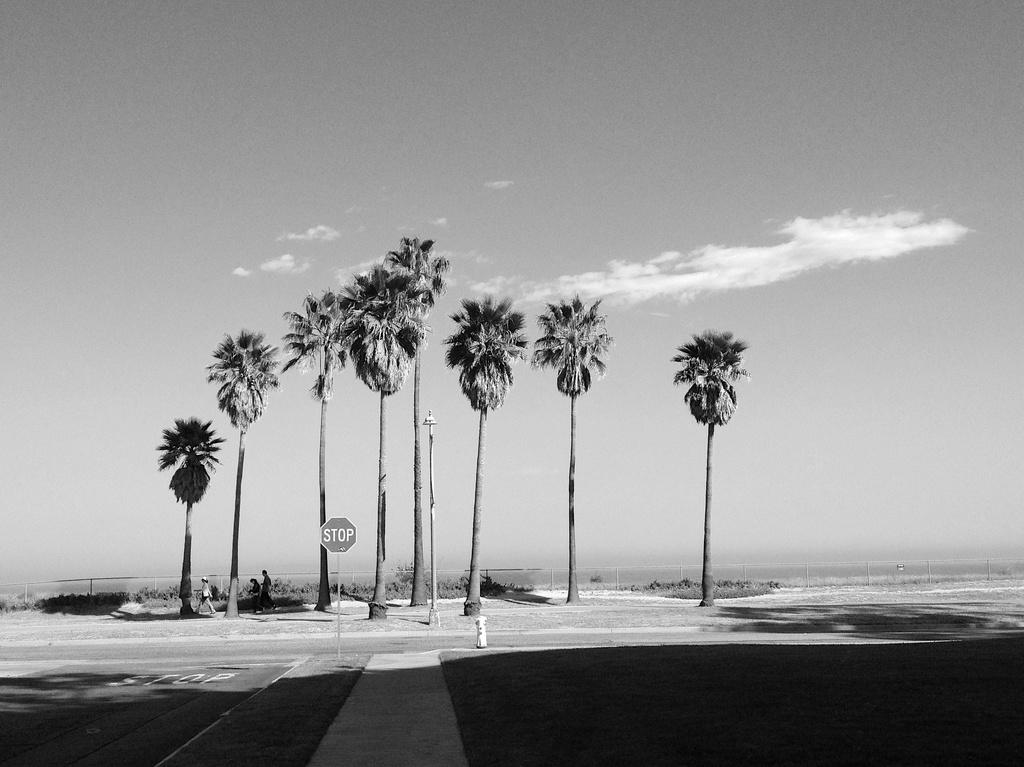What is the color scheme of the image? The image is black and white. What can be seen at the front of the image? There is a road in the front of the image. What is located in the middle of the road? There is a caution board in the middle of the road. What type of vegetation is visible in the background of the image? There are many coconut trees in the background of the image. What part of the natural environment is visible in the image? The sky is visible in the image. What can be observed in the sky? Clouds are present in the sky. What type of jeans is the tree wearing in the image? There are no jeans present in the image, as trees do not wear clothing. 